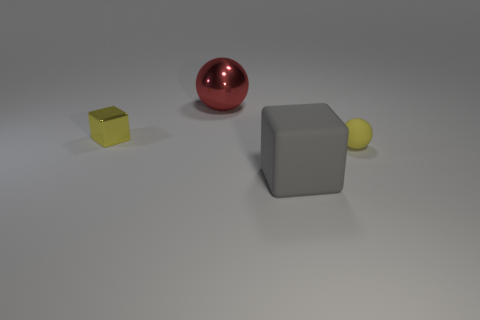The large matte object has what color?
Offer a terse response. Gray. Does the small rubber sphere have the same color as the tiny metal cube?
Your answer should be very brief. Yes. How many yellow spheres are in front of the metallic thing in front of the big red ball?
Your answer should be compact. 1. There is a thing that is in front of the red metal thing and to the left of the large gray block; how big is it?
Offer a terse response. Small. What is the big thing behind the yellow metal block made of?
Your answer should be very brief. Metal. Is there another small object of the same shape as the gray rubber object?
Ensure brevity in your answer.  Yes. How many other large red objects are the same shape as the red thing?
Offer a terse response. 0. Is the size of the yellow thing that is to the left of the matte ball the same as the thing behind the yellow cube?
Give a very brief answer. No. What is the shape of the tiny yellow thing that is behind the sphere right of the large red metal thing?
Give a very brief answer. Cube. Are there an equal number of yellow balls that are behind the small yellow shiny cube and big red spheres?
Make the answer very short. No. 